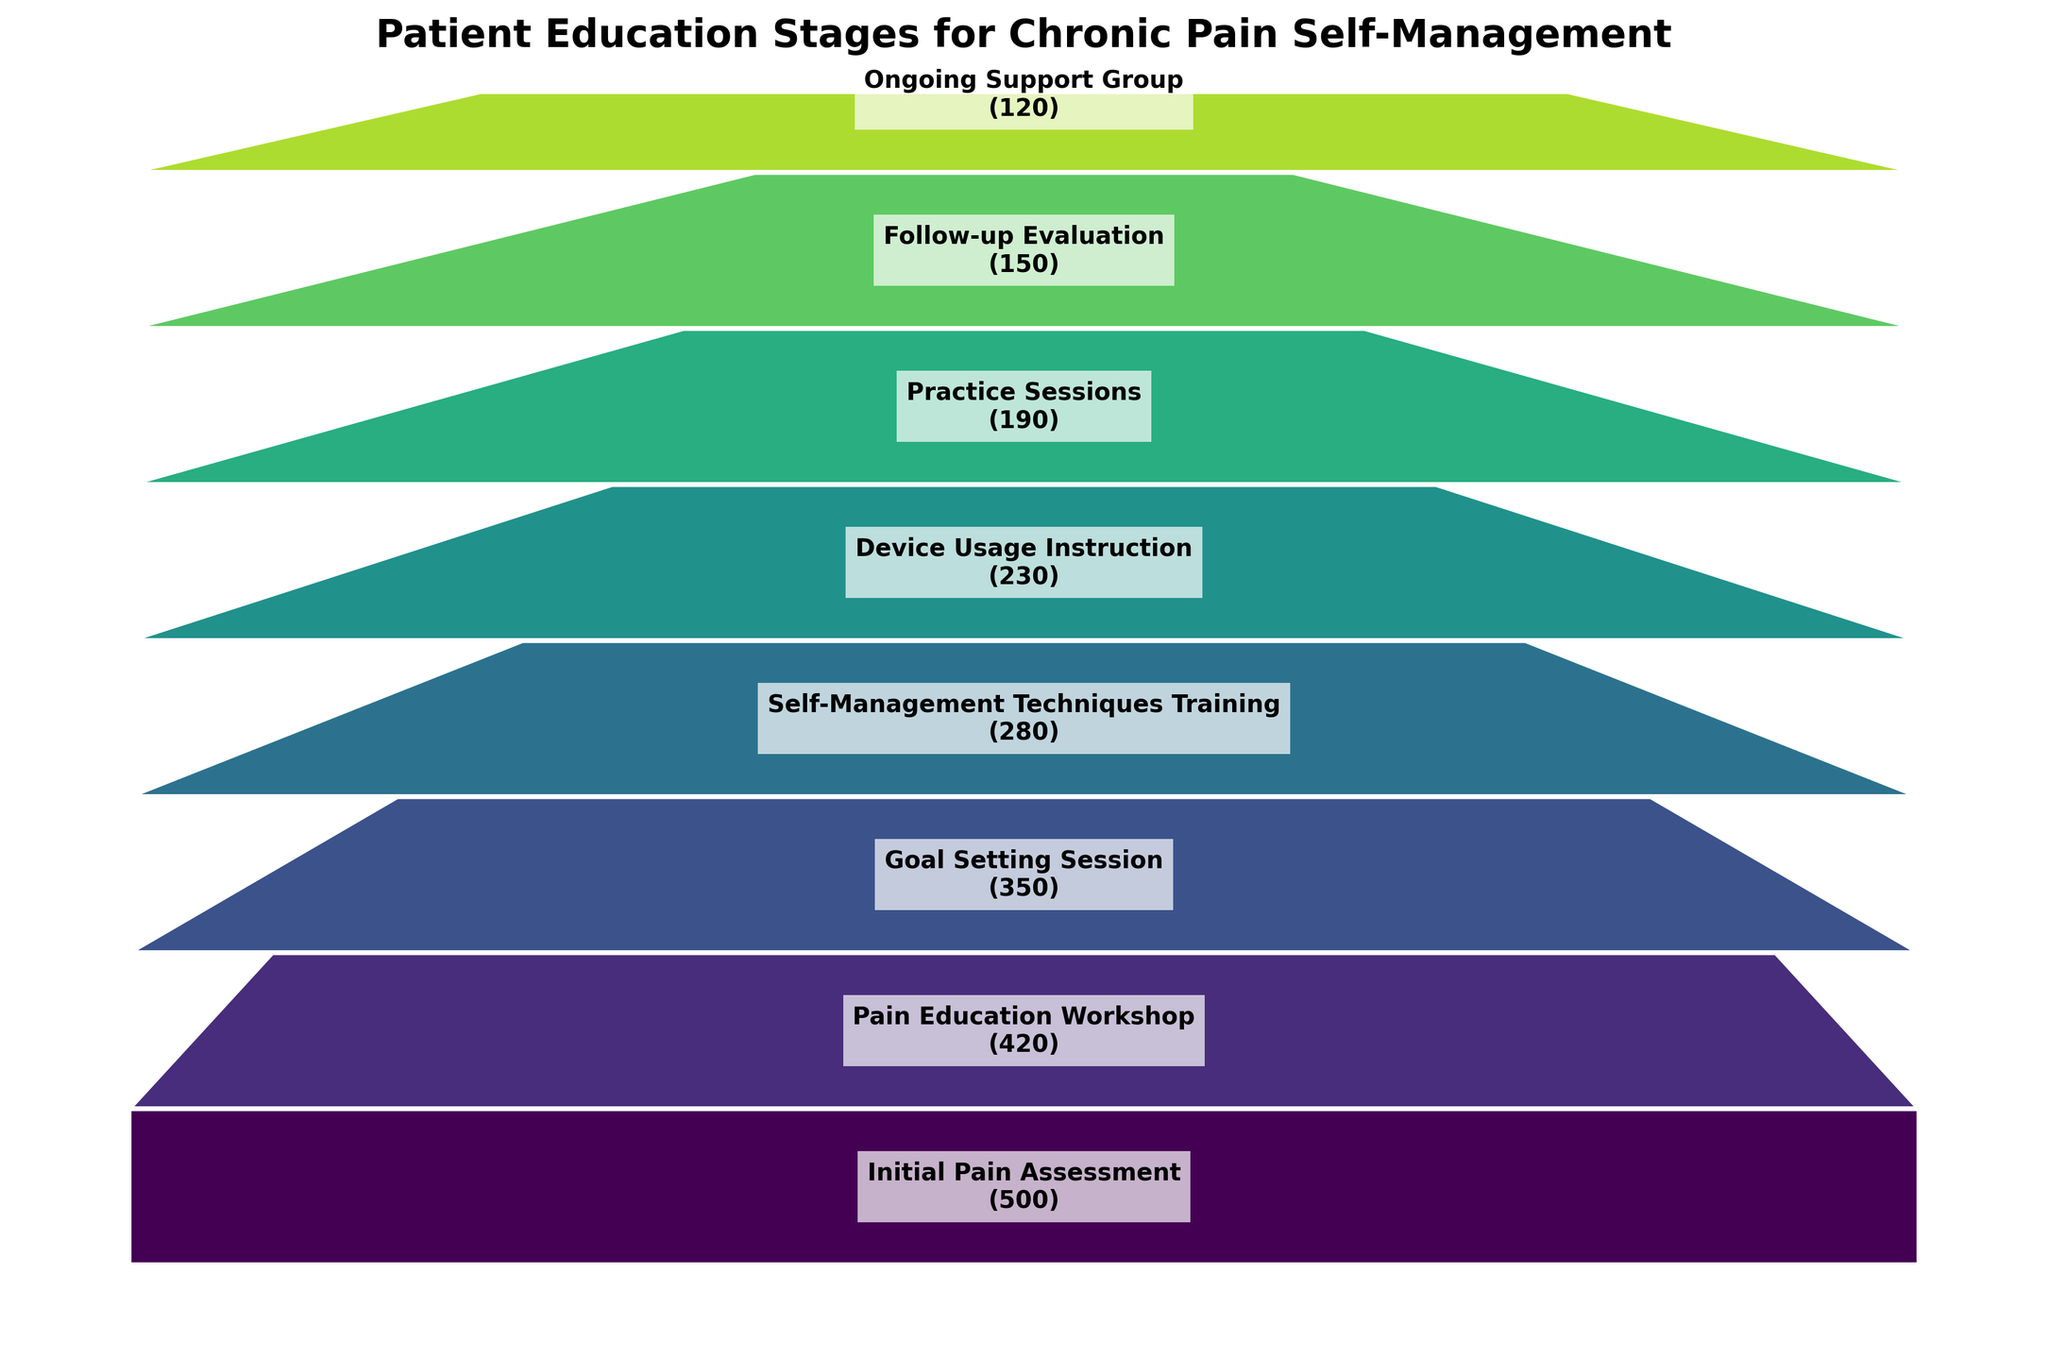What's the title of the figure? The title is located at the top of the figure and usually summarizes the main content. The title of this figure is: "Patient Education Stages for Chronic Pain Self-Management".
Answer: Patient Education Stages for Chronic Pain Self-Management How many stages are displayed in this funnel chart? To find the number of stages, count the distinct segments in the funnel chart. According to the data, there are segments for each stage.
Answer: 8 Which stage has the highest number of patients? The stage with the highest number of patients will be the widest segment at the top of the funnel. According to the data, the "Initial Pain Assessment" stage is at the top with 500 patients.
Answer: Initial Pain Assessment What is the difference in the number of patients between the "Goal Setting Session" and "Pain Education Workshop" stages? To find the difference, subtract the number of patients in the "Goal Setting Session" from those in the "Pain Education Workshop". According to the data, this would be 420 - 350.
Answer: 70 How many patients reach the "Follow-up Evaluation" stage? Identify the segment labeled "Follow-up Evaluation" and note the number of patients from the text. According to the data, there are 150 patients at this stage.
Answer: 150 What percentage of the initial patients participate in the "Device Usage Instruction" stage? To calculate this, divide the number of patients in the "Device Usage Instruction" stage by the number of initial patients and multiply by 100. According to the data: (230/500) * 100.
Answer: 46% How many fewer patients attend the "Ongoing Support Group" compared to the "Pain Education Workshop"? To find the difference, subtract the number of patients in the "Ongoing Support Group" from those in the "Pain Education Workshop". According to the data, it's 420 - 120.
Answer: 300 